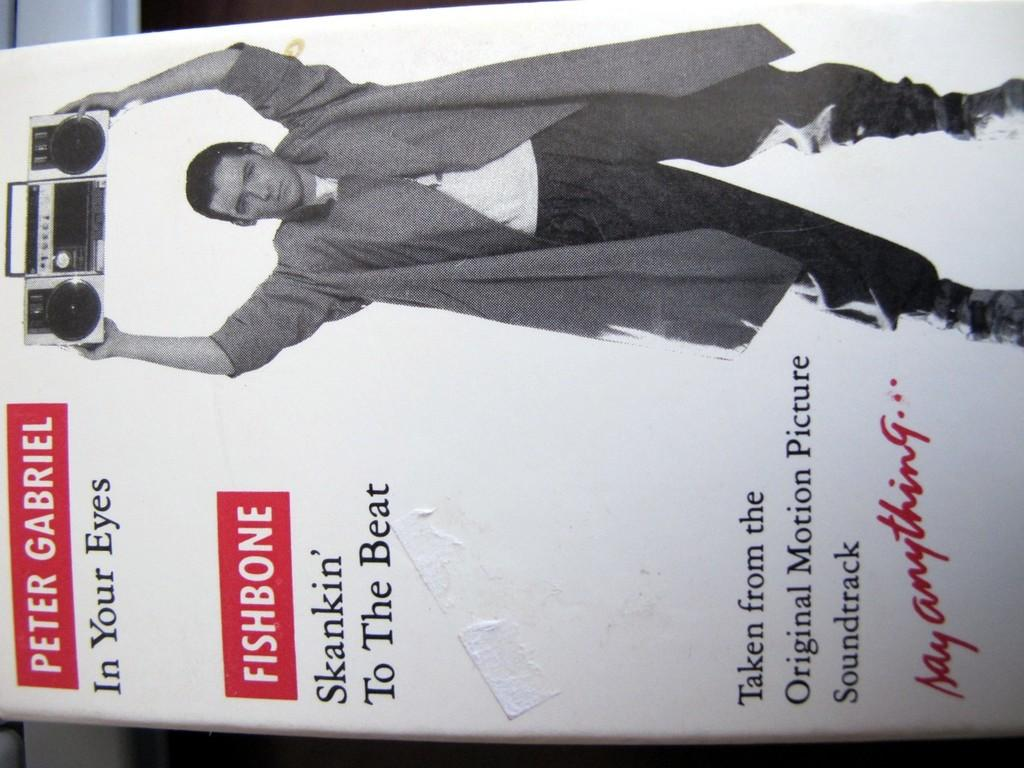What is the main object in the picture? There is a board in the picture. What is depicted on the board? There is a picture of a man on the board. What is the man in the picture holding? The man in the picture is holding a tape recorder. Are there any words or phrases written on the board? Yes, there is writing on the board. Can you tell me what the judge is saying on the moon in the image? There is no judge or moon present in the image; it features a board with a picture of a man holding a tape recorder. 